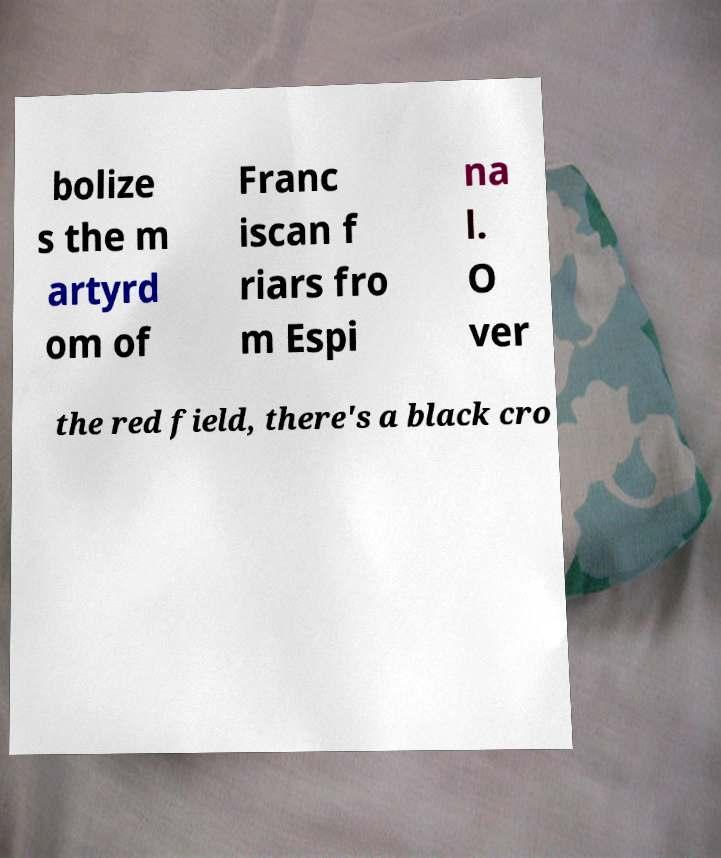There's text embedded in this image that I need extracted. Can you transcribe it verbatim? bolize s the m artyrd om of Franc iscan f riars fro m Espi na l. O ver the red field, there's a black cro 